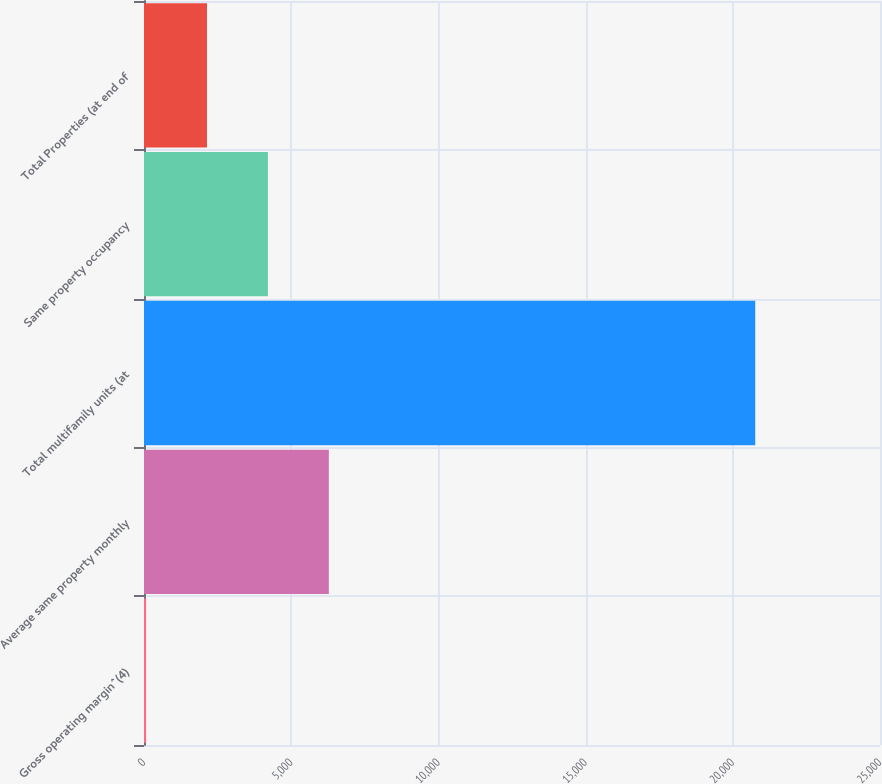<chart> <loc_0><loc_0><loc_500><loc_500><bar_chart><fcel>Gross operating margin^(4)<fcel>Average same property monthly<fcel>Total multifamily units (at<fcel>Same property occupancy<fcel>Total Properties (at end of<nl><fcel>71<fcel>6278.3<fcel>20762<fcel>4209.2<fcel>2140.1<nl></chart> 